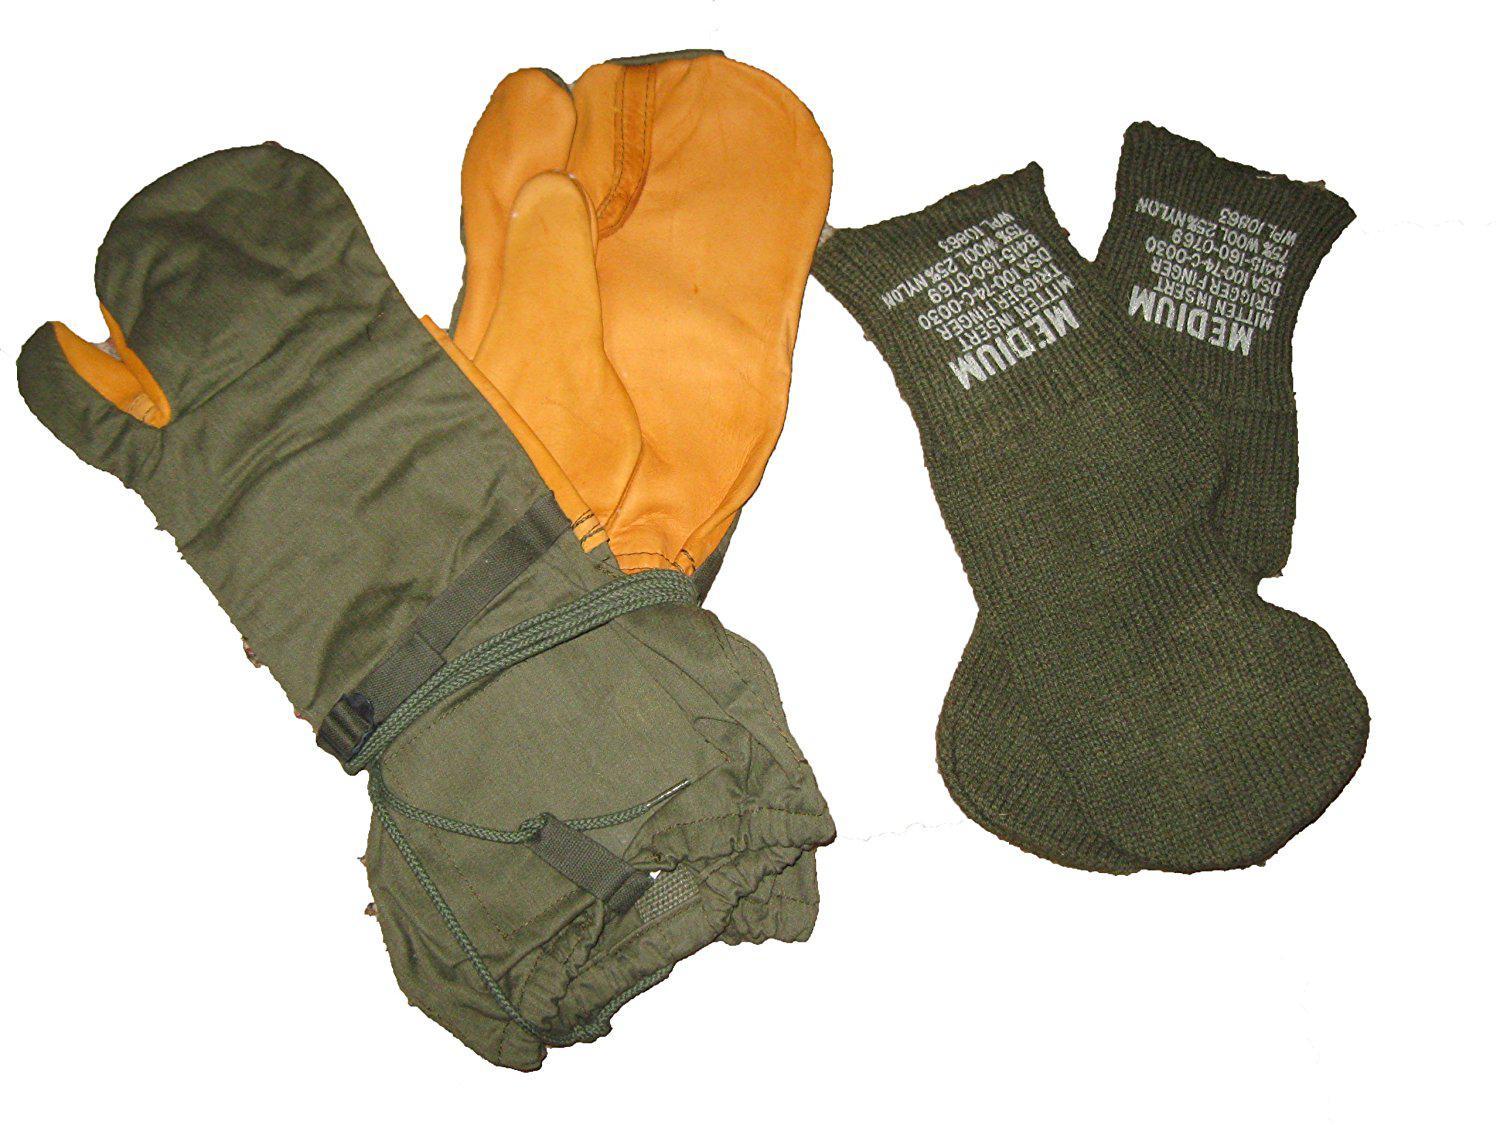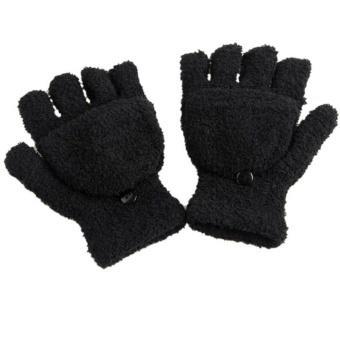The first image is the image on the left, the second image is the image on the right. For the images shown, is this caption "One of the pairs of mittens is the open-fingered style." true? Answer yes or no. Yes. The first image is the image on the left, the second image is the image on the right. Examine the images to the left and right. Is the description "Some of the mittens or gloves are furry and none of them are being worn." accurate? Answer yes or no. Yes. 